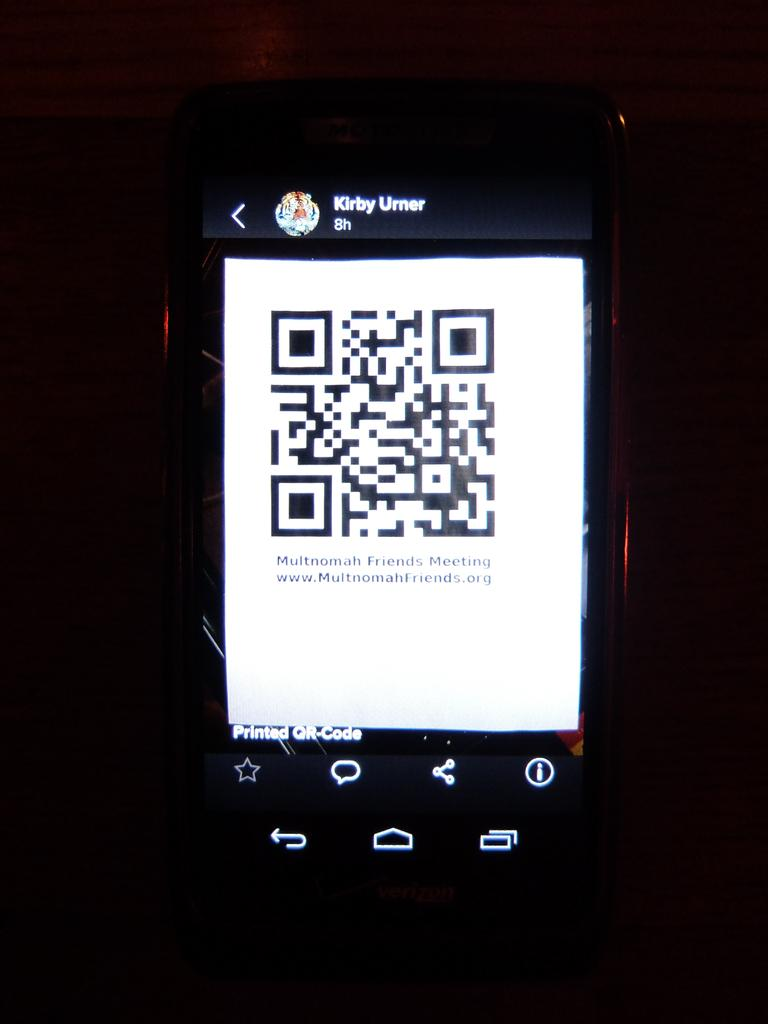<image>
Write a terse but informative summary of the picture. A phone display with the name Kirby Umer on the very top. 